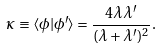<formula> <loc_0><loc_0><loc_500><loc_500>\kappa \equiv \langle \phi | \phi ^ { \prime } \rangle = \frac { 4 \lambda \lambda ^ { \prime } } { ( \lambda + \lambda ^ { \prime } ) ^ { 2 } } .</formula> 